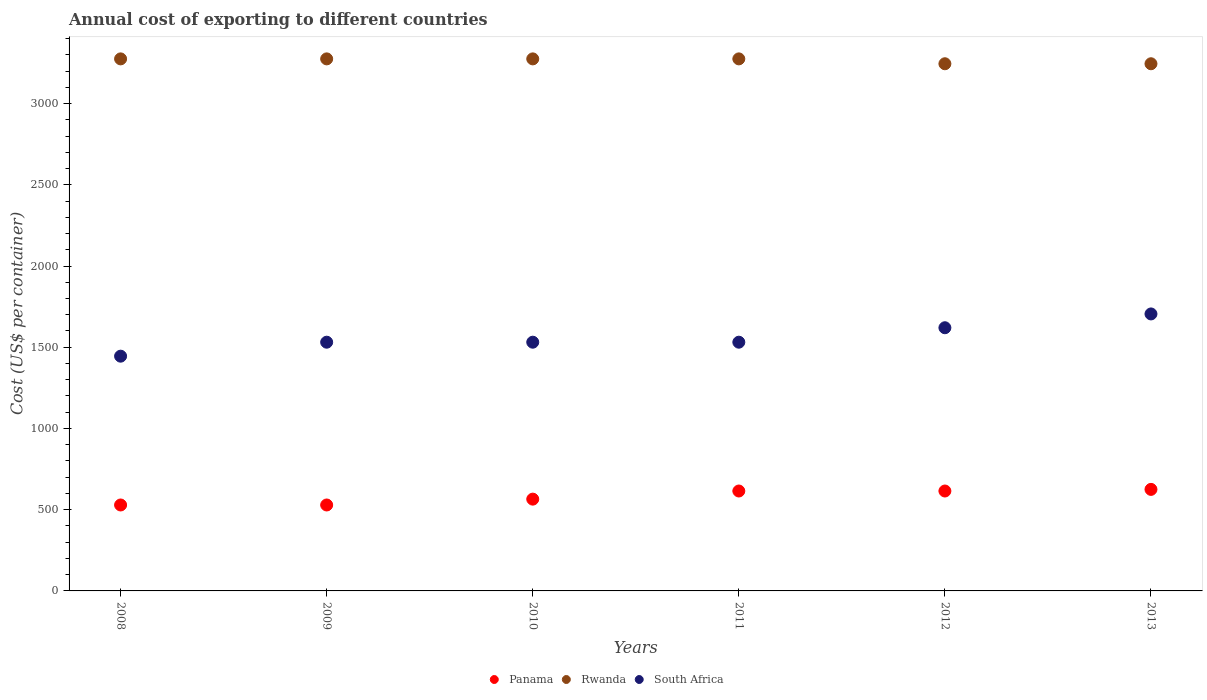How many different coloured dotlines are there?
Provide a succinct answer. 3. What is the total annual cost of exporting in Rwanda in 2008?
Give a very brief answer. 3275. Across all years, what is the maximum total annual cost of exporting in South Africa?
Offer a terse response. 1705. Across all years, what is the minimum total annual cost of exporting in Panama?
Your response must be concise. 529. What is the total total annual cost of exporting in Panama in the graph?
Ensure brevity in your answer.  3478. What is the difference between the total annual cost of exporting in Rwanda in 2012 and that in 2013?
Your answer should be compact. 0. What is the difference between the total annual cost of exporting in South Africa in 2010 and the total annual cost of exporting in Panama in 2009?
Keep it short and to the point. 1002. What is the average total annual cost of exporting in South Africa per year?
Keep it short and to the point. 1560.5. In the year 2012, what is the difference between the total annual cost of exporting in Panama and total annual cost of exporting in South Africa?
Your answer should be compact. -1005. In how many years, is the total annual cost of exporting in Rwanda greater than 1400 US$?
Offer a very short reply. 6. What is the ratio of the total annual cost of exporting in Panama in 2009 to that in 2011?
Your answer should be compact. 0.86. What is the difference between the highest and the lowest total annual cost of exporting in Panama?
Give a very brief answer. 96. Is the sum of the total annual cost of exporting in Panama in 2012 and 2013 greater than the maximum total annual cost of exporting in South Africa across all years?
Your answer should be compact. No. Is it the case that in every year, the sum of the total annual cost of exporting in South Africa and total annual cost of exporting in Panama  is greater than the total annual cost of exporting in Rwanda?
Ensure brevity in your answer.  No. Is the total annual cost of exporting in South Africa strictly greater than the total annual cost of exporting in Rwanda over the years?
Ensure brevity in your answer.  No. Is the total annual cost of exporting in Panama strictly less than the total annual cost of exporting in South Africa over the years?
Your response must be concise. Yes. How many dotlines are there?
Keep it short and to the point. 3. How are the legend labels stacked?
Make the answer very short. Horizontal. What is the title of the graph?
Ensure brevity in your answer.  Annual cost of exporting to different countries. Does "Brazil" appear as one of the legend labels in the graph?
Offer a very short reply. No. What is the label or title of the Y-axis?
Give a very brief answer. Cost (US$ per container). What is the Cost (US$ per container) of Panama in 2008?
Provide a short and direct response. 529. What is the Cost (US$ per container) in Rwanda in 2008?
Your response must be concise. 3275. What is the Cost (US$ per container) in South Africa in 2008?
Provide a short and direct response. 1445. What is the Cost (US$ per container) of Panama in 2009?
Make the answer very short. 529. What is the Cost (US$ per container) in Rwanda in 2009?
Provide a short and direct response. 3275. What is the Cost (US$ per container) of South Africa in 2009?
Give a very brief answer. 1531. What is the Cost (US$ per container) of Panama in 2010?
Offer a very short reply. 565. What is the Cost (US$ per container) in Rwanda in 2010?
Ensure brevity in your answer.  3275. What is the Cost (US$ per container) of South Africa in 2010?
Your answer should be very brief. 1531. What is the Cost (US$ per container) in Panama in 2011?
Provide a short and direct response. 615. What is the Cost (US$ per container) of Rwanda in 2011?
Ensure brevity in your answer.  3275. What is the Cost (US$ per container) of South Africa in 2011?
Your answer should be very brief. 1531. What is the Cost (US$ per container) in Panama in 2012?
Ensure brevity in your answer.  615. What is the Cost (US$ per container) of Rwanda in 2012?
Provide a short and direct response. 3245. What is the Cost (US$ per container) in South Africa in 2012?
Offer a terse response. 1620. What is the Cost (US$ per container) of Panama in 2013?
Your answer should be very brief. 625. What is the Cost (US$ per container) of Rwanda in 2013?
Make the answer very short. 3245. What is the Cost (US$ per container) of South Africa in 2013?
Ensure brevity in your answer.  1705. Across all years, what is the maximum Cost (US$ per container) of Panama?
Offer a terse response. 625. Across all years, what is the maximum Cost (US$ per container) in Rwanda?
Provide a succinct answer. 3275. Across all years, what is the maximum Cost (US$ per container) of South Africa?
Provide a succinct answer. 1705. Across all years, what is the minimum Cost (US$ per container) in Panama?
Give a very brief answer. 529. Across all years, what is the minimum Cost (US$ per container) in Rwanda?
Give a very brief answer. 3245. Across all years, what is the minimum Cost (US$ per container) in South Africa?
Offer a terse response. 1445. What is the total Cost (US$ per container) of Panama in the graph?
Make the answer very short. 3478. What is the total Cost (US$ per container) in Rwanda in the graph?
Your response must be concise. 1.96e+04. What is the total Cost (US$ per container) of South Africa in the graph?
Make the answer very short. 9363. What is the difference between the Cost (US$ per container) of Panama in 2008 and that in 2009?
Give a very brief answer. 0. What is the difference between the Cost (US$ per container) of South Africa in 2008 and that in 2009?
Provide a succinct answer. -86. What is the difference between the Cost (US$ per container) of Panama in 2008 and that in 2010?
Your answer should be very brief. -36. What is the difference between the Cost (US$ per container) in Rwanda in 2008 and that in 2010?
Give a very brief answer. 0. What is the difference between the Cost (US$ per container) in South Africa in 2008 and that in 2010?
Make the answer very short. -86. What is the difference between the Cost (US$ per container) of Panama in 2008 and that in 2011?
Your answer should be very brief. -86. What is the difference between the Cost (US$ per container) in Rwanda in 2008 and that in 2011?
Offer a terse response. 0. What is the difference between the Cost (US$ per container) of South Africa in 2008 and that in 2011?
Offer a very short reply. -86. What is the difference between the Cost (US$ per container) in Panama in 2008 and that in 2012?
Provide a short and direct response. -86. What is the difference between the Cost (US$ per container) in South Africa in 2008 and that in 2012?
Your answer should be compact. -175. What is the difference between the Cost (US$ per container) in Panama in 2008 and that in 2013?
Your answer should be compact. -96. What is the difference between the Cost (US$ per container) in Rwanda in 2008 and that in 2013?
Keep it short and to the point. 30. What is the difference between the Cost (US$ per container) in South Africa in 2008 and that in 2013?
Your answer should be very brief. -260. What is the difference between the Cost (US$ per container) of Panama in 2009 and that in 2010?
Keep it short and to the point. -36. What is the difference between the Cost (US$ per container) in Rwanda in 2009 and that in 2010?
Ensure brevity in your answer.  0. What is the difference between the Cost (US$ per container) in South Africa in 2009 and that in 2010?
Your response must be concise. 0. What is the difference between the Cost (US$ per container) of Panama in 2009 and that in 2011?
Ensure brevity in your answer.  -86. What is the difference between the Cost (US$ per container) in Rwanda in 2009 and that in 2011?
Offer a terse response. 0. What is the difference between the Cost (US$ per container) in South Africa in 2009 and that in 2011?
Your response must be concise. 0. What is the difference between the Cost (US$ per container) in Panama in 2009 and that in 2012?
Provide a short and direct response. -86. What is the difference between the Cost (US$ per container) of Rwanda in 2009 and that in 2012?
Your response must be concise. 30. What is the difference between the Cost (US$ per container) of South Africa in 2009 and that in 2012?
Provide a succinct answer. -89. What is the difference between the Cost (US$ per container) in Panama in 2009 and that in 2013?
Give a very brief answer. -96. What is the difference between the Cost (US$ per container) of Rwanda in 2009 and that in 2013?
Your answer should be compact. 30. What is the difference between the Cost (US$ per container) of South Africa in 2009 and that in 2013?
Keep it short and to the point. -174. What is the difference between the Cost (US$ per container) in Panama in 2010 and that in 2011?
Your answer should be very brief. -50. What is the difference between the Cost (US$ per container) in South Africa in 2010 and that in 2011?
Your answer should be compact. 0. What is the difference between the Cost (US$ per container) in Panama in 2010 and that in 2012?
Make the answer very short. -50. What is the difference between the Cost (US$ per container) of Rwanda in 2010 and that in 2012?
Offer a terse response. 30. What is the difference between the Cost (US$ per container) in South Africa in 2010 and that in 2012?
Provide a succinct answer. -89. What is the difference between the Cost (US$ per container) of Panama in 2010 and that in 2013?
Make the answer very short. -60. What is the difference between the Cost (US$ per container) of South Africa in 2010 and that in 2013?
Provide a short and direct response. -174. What is the difference between the Cost (US$ per container) in Panama in 2011 and that in 2012?
Keep it short and to the point. 0. What is the difference between the Cost (US$ per container) in South Africa in 2011 and that in 2012?
Offer a terse response. -89. What is the difference between the Cost (US$ per container) of Panama in 2011 and that in 2013?
Keep it short and to the point. -10. What is the difference between the Cost (US$ per container) in Rwanda in 2011 and that in 2013?
Make the answer very short. 30. What is the difference between the Cost (US$ per container) in South Africa in 2011 and that in 2013?
Your answer should be compact. -174. What is the difference between the Cost (US$ per container) of South Africa in 2012 and that in 2013?
Give a very brief answer. -85. What is the difference between the Cost (US$ per container) in Panama in 2008 and the Cost (US$ per container) in Rwanda in 2009?
Offer a very short reply. -2746. What is the difference between the Cost (US$ per container) in Panama in 2008 and the Cost (US$ per container) in South Africa in 2009?
Give a very brief answer. -1002. What is the difference between the Cost (US$ per container) in Rwanda in 2008 and the Cost (US$ per container) in South Africa in 2009?
Keep it short and to the point. 1744. What is the difference between the Cost (US$ per container) of Panama in 2008 and the Cost (US$ per container) of Rwanda in 2010?
Your answer should be compact. -2746. What is the difference between the Cost (US$ per container) in Panama in 2008 and the Cost (US$ per container) in South Africa in 2010?
Offer a terse response. -1002. What is the difference between the Cost (US$ per container) in Rwanda in 2008 and the Cost (US$ per container) in South Africa in 2010?
Your answer should be compact. 1744. What is the difference between the Cost (US$ per container) of Panama in 2008 and the Cost (US$ per container) of Rwanda in 2011?
Give a very brief answer. -2746. What is the difference between the Cost (US$ per container) of Panama in 2008 and the Cost (US$ per container) of South Africa in 2011?
Make the answer very short. -1002. What is the difference between the Cost (US$ per container) in Rwanda in 2008 and the Cost (US$ per container) in South Africa in 2011?
Offer a terse response. 1744. What is the difference between the Cost (US$ per container) in Panama in 2008 and the Cost (US$ per container) in Rwanda in 2012?
Your answer should be compact. -2716. What is the difference between the Cost (US$ per container) in Panama in 2008 and the Cost (US$ per container) in South Africa in 2012?
Your response must be concise. -1091. What is the difference between the Cost (US$ per container) of Rwanda in 2008 and the Cost (US$ per container) of South Africa in 2012?
Keep it short and to the point. 1655. What is the difference between the Cost (US$ per container) of Panama in 2008 and the Cost (US$ per container) of Rwanda in 2013?
Provide a short and direct response. -2716. What is the difference between the Cost (US$ per container) in Panama in 2008 and the Cost (US$ per container) in South Africa in 2013?
Your response must be concise. -1176. What is the difference between the Cost (US$ per container) of Rwanda in 2008 and the Cost (US$ per container) of South Africa in 2013?
Your answer should be compact. 1570. What is the difference between the Cost (US$ per container) in Panama in 2009 and the Cost (US$ per container) in Rwanda in 2010?
Your response must be concise. -2746. What is the difference between the Cost (US$ per container) of Panama in 2009 and the Cost (US$ per container) of South Africa in 2010?
Your answer should be compact. -1002. What is the difference between the Cost (US$ per container) in Rwanda in 2009 and the Cost (US$ per container) in South Africa in 2010?
Keep it short and to the point. 1744. What is the difference between the Cost (US$ per container) of Panama in 2009 and the Cost (US$ per container) of Rwanda in 2011?
Keep it short and to the point. -2746. What is the difference between the Cost (US$ per container) of Panama in 2009 and the Cost (US$ per container) of South Africa in 2011?
Keep it short and to the point. -1002. What is the difference between the Cost (US$ per container) of Rwanda in 2009 and the Cost (US$ per container) of South Africa in 2011?
Your answer should be compact. 1744. What is the difference between the Cost (US$ per container) of Panama in 2009 and the Cost (US$ per container) of Rwanda in 2012?
Your response must be concise. -2716. What is the difference between the Cost (US$ per container) of Panama in 2009 and the Cost (US$ per container) of South Africa in 2012?
Provide a short and direct response. -1091. What is the difference between the Cost (US$ per container) in Rwanda in 2009 and the Cost (US$ per container) in South Africa in 2012?
Offer a very short reply. 1655. What is the difference between the Cost (US$ per container) of Panama in 2009 and the Cost (US$ per container) of Rwanda in 2013?
Your answer should be very brief. -2716. What is the difference between the Cost (US$ per container) of Panama in 2009 and the Cost (US$ per container) of South Africa in 2013?
Offer a very short reply. -1176. What is the difference between the Cost (US$ per container) of Rwanda in 2009 and the Cost (US$ per container) of South Africa in 2013?
Keep it short and to the point. 1570. What is the difference between the Cost (US$ per container) of Panama in 2010 and the Cost (US$ per container) of Rwanda in 2011?
Keep it short and to the point. -2710. What is the difference between the Cost (US$ per container) in Panama in 2010 and the Cost (US$ per container) in South Africa in 2011?
Provide a succinct answer. -966. What is the difference between the Cost (US$ per container) of Rwanda in 2010 and the Cost (US$ per container) of South Africa in 2011?
Your response must be concise. 1744. What is the difference between the Cost (US$ per container) of Panama in 2010 and the Cost (US$ per container) of Rwanda in 2012?
Your response must be concise. -2680. What is the difference between the Cost (US$ per container) in Panama in 2010 and the Cost (US$ per container) in South Africa in 2012?
Offer a terse response. -1055. What is the difference between the Cost (US$ per container) of Rwanda in 2010 and the Cost (US$ per container) of South Africa in 2012?
Ensure brevity in your answer.  1655. What is the difference between the Cost (US$ per container) in Panama in 2010 and the Cost (US$ per container) in Rwanda in 2013?
Give a very brief answer. -2680. What is the difference between the Cost (US$ per container) of Panama in 2010 and the Cost (US$ per container) of South Africa in 2013?
Your answer should be compact. -1140. What is the difference between the Cost (US$ per container) of Rwanda in 2010 and the Cost (US$ per container) of South Africa in 2013?
Offer a terse response. 1570. What is the difference between the Cost (US$ per container) of Panama in 2011 and the Cost (US$ per container) of Rwanda in 2012?
Offer a terse response. -2630. What is the difference between the Cost (US$ per container) in Panama in 2011 and the Cost (US$ per container) in South Africa in 2012?
Your answer should be very brief. -1005. What is the difference between the Cost (US$ per container) of Rwanda in 2011 and the Cost (US$ per container) of South Africa in 2012?
Your answer should be very brief. 1655. What is the difference between the Cost (US$ per container) in Panama in 2011 and the Cost (US$ per container) in Rwanda in 2013?
Make the answer very short. -2630. What is the difference between the Cost (US$ per container) of Panama in 2011 and the Cost (US$ per container) of South Africa in 2013?
Make the answer very short. -1090. What is the difference between the Cost (US$ per container) of Rwanda in 2011 and the Cost (US$ per container) of South Africa in 2013?
Give a very brief answer. 1570. What is the difference between the Cost (US$ per container) of Panama in 2012 and the Cost (US$ per container) of Rwanda in 2013?
Keep it short and to the point. -2630. What is the difference between the Cost (US$ per container) in Panama in 2012 and the Cost (US$ per container) in South Africa in 2013?
Keep it short and to the point. -1090. What is the difference between the Cost (US$ per container) in Rwanda in 2012 and the Cost (US$ per container) in South Africa in 2013?
Offer a very short reply. 1540. What is the average Cost (US$ per container) of Panama per year?
Keep it short and to the point. 579.67. What is the average Cost (US$ per container) of Rwanda per year?
Make the answer very short. 3265. What is the average Cost (US$ per container) in South Africa per year?
Your answer should be compact. 1560.5. In the year 2008, what is the difference between the Cost (US$ per container) in Panama and Cost (US$ per container) in Rwanda?
Your response must be concise. -2746. In the year 2008, what is the difference between the Cost (US$ per container) of Panama and Cost (US$ per container) of South Africa?
Your answer should be very brief. -916. In the year 2008, what is the difference between the Cost (US$ per container) of Rwanda and Cost (US$ per container) of South Africa?
Your answer should be compact. 1830. In the year 2009, what is the difference between the Cost (US$ per container) in Panama and Cost (US$ per container) in Rwanda?
Your response must be concise. -2746. In the year 2009, what is the difference between the Cost (US$ per container) of Panama and Cost (US$ per container) of South Africa?
Ensure brevity in your answer.  -1002. In the year 2009, what is the difference between the Cost (US$ per container) in Rwanda and Cost (US$ per container) in South Africa?
Your answer should be compact. 1744. In the year 2010, what is the difference between the Cost (US$ per container) of Panama and Cost (US$ per container) of Rwanda?
Offer a terse response. -2710. In the year 2010, what is the difference between the Cost (US$ per container) in Panama and Cost (US$ per container) in South Africa?
Give a very brief answer. -966. In the year 2010, what is the difference between the Cost (US$ per container) of Rwanda and Cost (US$ per container) of South Africa?
Offer a terse response. 1744. In the year 2011, what is the difference between the Cost (US$ per container) of Panama and Cost (US$ per container) of Rwanda?
Your response must be concise. -2660. In the year 2011, what is the difference between the Cost (US$ per container) of Panama and Cost (US$ per container) of South Africa?
Provide a short and direct response. -916. In the year 2011, what is the difference between the Cost (US$ per container) in Rwanda and Cost (US$ per container) in South Africa?
Your answer should be compact. 1744. In the year 2012, what is the difference between the Cost (US$ per container) of Panama and Cost (US$ per container) of Rwanda?
Provide a short and direct response. -2630. In the year 2012, what is the difference between the Cost (US$ per container) of Panama and Cost (US$ per container) of South Africa?
Ensure brevity in your answer.  -1005. In the year 2012, what is the difference between the Cost (US$ per container) of Rwanda and Cost (US$ per container) of South Africa?
Make the answer very short. 1625. In the year 2013, what is the difference between the Cost (US$ per container) of Panama and Cost (US$ per container) of Rwanda?
Your response must be concise. -2620. In the year 2013, what is the difference between the Cost (US$ per container) of Panama and Cost (US$ per container) of South Africa?
Offer a very short reply. -1080. In the year 2013, what is the difference between the Cost (US$ per container) in Rwanda and Cost (US$ per container) in South Africa?
Your response must be concise. 1540. What is the ratio of the Cost (US$ per container) of Panama in 2008 to that in 2009?
Your answer should be very brief. 1. What is the ratio of the Cost (US$ per container) of South Africa in 2008 to that in 2009?
Your answer should be very brief. 0.94. What is the ratio of the Cost (US$ per container) of Panama in 2008 to that in 2010?
Ensure brevity in your answer.  0.94. What is the ratio of the Cost (US$ per container) in South Africa in 2008 to that in 2010?
Provide a short and direct response. 0.94. What is the ratio of the Cost (US$ per container) in Panama in 2008 to that in 2011?
Offer a terse response. 0.86. What is the ratio of the Cost (US$ per container) in South Africa in 2008 to that in 2011?
Ensure brevity in your answer.  0.94. What is the ratio of the Cost (US$ per container) in Panama in 2008 to that in 2012?
Offer a very short reply. 0.86. What is the ratio of the Cost (US$ per container) of Rwanda in 2008 to that in 2012?
Your response must be concise. 1.01. What is the ratio of the Cost (US$ per container) of South Africa in 2008 to that in 2012?
Offer a terse response. 0.89. What is the ratio of the Cost (US$ per container) of Panama in 2008 to that in 2013?
Your answer should be compact. 0.85. What is the ratio of the Cost (US$ per container) of Rwanda in 2008 to that in 2013?
Provide a short and direct response. 1.01. What is the ratio of the Cost (US$ per container) in South Africa in 2008 to that in 2013?
Keep it short and to the point. 0.85. What is the ratio of the Cost (US$ per container) in Panama in 2009 to that in 2010?
Ensure brevity in your answer.  0.94. What is the ratio of the Cost (US$ per container) in Panama in 2009 to that in 2011?
Make the answer very short. 0.86. What is the ratio of the Cost (US$ per container) in South Africa in 2009 to that in 2011?
Give a very brief answer. 1. What is the ratio of the Cost (US$ per container) of Panama in 2009 to that in 2012?
Your response must be concise. 0.86. What is the ratio of the Cost (US$ per container) of Rwanda in 2009 to that in 2012?
Your response must be concise. 1.01. What is the ratio of the Cost (US$ per container) in South Africa in 2009 to that in 2012?
Give a very brief answer. 0.95. What is the ratio of the Cost (US$ per container) of Panama in 2009 to that in 2013?
Your answer should be very brief. 0.85. What is the ratio of the Cost (US$ per container) in Rwanda in 2009 to that in 2013?
Provide a short and direct response. 1.01. What is the ratio of the Cost (US$ per container) of South Africa in 2009 to that in 2013?
Give a very brief answer. 0.9. What is the ratio of the Cost (US$ per container) of Panama in 2010 to that in 2011?
Keep it short and to the point. 0.92. What is the ratio of the Cost (US$ per container) of South Africa in 2010 to that in 2011?
Keep it short and to the point. 1. What is the ratio of the Cost (US$ per container) in Panama in 2010 to that in 2012?
Give a very brief answer. 0.92. What is the ratio of the Cost (US$ per container) in Rwanda in 2010 to that in 2012?
Your answer should be very brief. 1.01. What is the ratio of the Cost (US$ per container) in South Africa in 2010 to that in 2012?
Offer a very short reply. 0.95. What is the ratio of the Cost (US$ per container) in Panama in 2010 to that in 2013?
Provide a short and direct response. 0.9. What is the ratio of the Cost (US$ per container) of Rwanda in 2010 to that in 2013?
Give a very brief answer. 1.01. What is the ratio of the Cost (US$ per container) in South Africa in 2010 to that in 2013?
Your answer should be very brief. 0.9. What is the ratio of the Cost (US$ per container) of Panama in 2011 to that in 2012?
Offer a terse response. 1. What is the ratio of the Cost (US$ per container) in Rwanda in 2011 to that in 2012?
Make the answer very short. 1.01. What is the ratio of the Cost (US$ per container) of South Africa in 2011 to that in 2012?
Ensure brevity in your answer.  0.95. What is the ratio of the Cost (US$ per container) in Panama in 2011 to that in 2013?
Provide a short and direct response. 0.98. What is the ratio of the Cost (US$ per container) in Rwanda in 2011 to that in 2013?
Offer a terse response. 1.01. What is the ratio of the Cost (US$ per container) of South Africa in 2011 to that in 2013?
Provide a short and direct response. 0.9. What is the ratio of the Cost (US$ per container) of Panama in 2012 to that in 2013?
Your answer should be very brief. 0.98. What is the ratio of the Cost (US$ per container) of Rwanda in 2012 to that in 2013?
Provide a short and direct response. 1. What is the ratio of the Cost (US$ per container) in South Africa in 2012 to that in 2013?
Give a very brief answer. 0.95. What is the difference between the highest and the second highest Cost (US$ per container) in Panama?
Ensure brevity in your answer.  10. What is the difference between the highest and the second highest Cost (US$ per container) of South Africa?
Offer a terse response. 85. What is the difference between the highest and the lowest Cost (US$ per container) in Panama?
Provide a short and direct response. 96. What is the difference between the highest and the lowest Cost (US$ per container) of South Africa?
Ensure brevity in your answer.  260. 